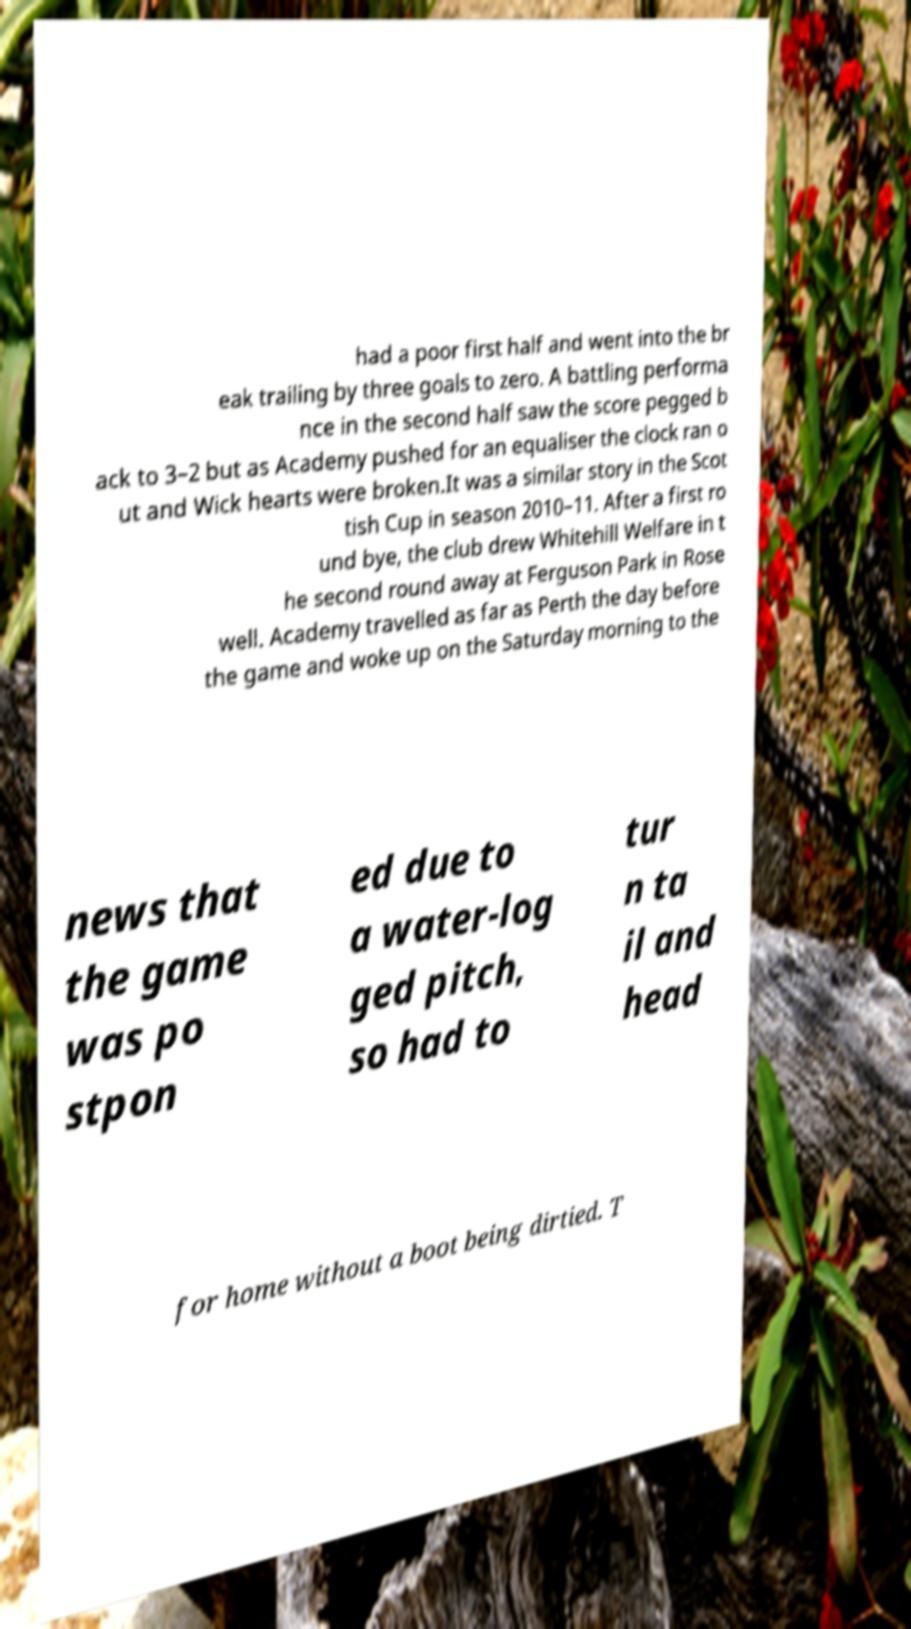There's text embedded in this image that I need extracted. Can you transcribe it verbatim? had a poor first half and went into the br eak trailing by three goals to zero. A battling performa nce in the second half saw the score pegged b ack to 3–2 but as Academy pushed for an equaliser the clock ran o ut and Wick hearts were broken.It was a similar story in the Scot tish Cup in season 2010–11. After a first ro und bye, the club drew Whitehill Welfare in t he second round away at Ferguson Park in Rose well. Academy travelled as far as Perth the day before the game and woke up on the Saturday morning to the news that the game was po stpon ed due to a water-log ged pitch, so had to tur n ta il and head for home without a boot being dirtied. T 